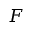Convert formula to latex. <formula><loc_0><loc_0><loc_500><loc_500>F</formula> 